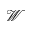Convert formula to latex. <formula><loc_0><loc_0><loc_500><loc_500>\mathcal { W }</formula> 